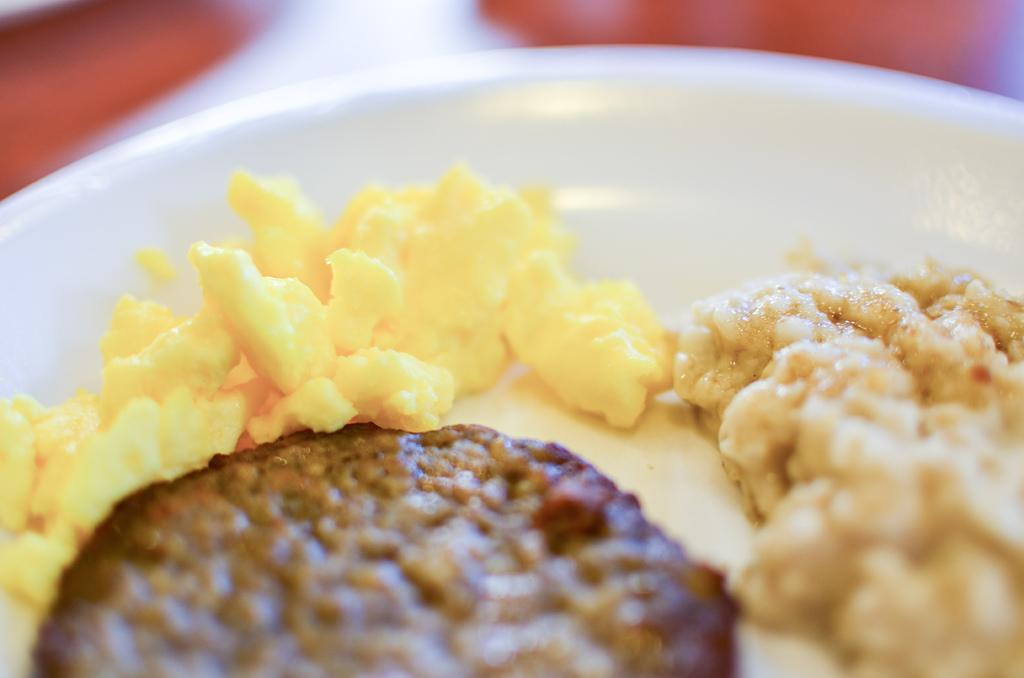What is the color of the plate in the image? The plate in the image is white. What types of food can be seen on the plate? There are yellow and brown color food items on the plate. What is the main argument presented in the image? There is no argument present in the image; it features a white plate with yellow and brown color food items. 